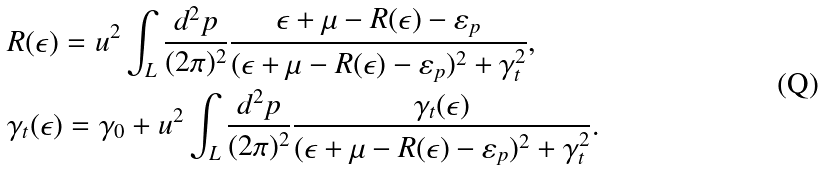Convert formula to latex. <formula><loc_0><loc_0><loc_500><loc_500>& R ( \epsilon ) = u ^ { 2 } \int _ { L } \frac { d ^ { 2 } p } { ( 2 \pi ) ^ { 2 } } \frac { \epsilon + \mu - R ( \epsilon ) - \varepsilon _ { p } } { ( \epsilon + \mu - R ( \epsilon ) - \varepsilon _ { p } ) ^ { 2 } + \gamma _ { t } ^ { 2 } } , \\ & \gamma _ { t } ( \epsilon ) = \gamma _ { 0 } + u ^ { 2 } \int _ { L } \frac { d ^ { 2 } p } { ( 2 \pi ) ^ { 2 } } \frac { \gamma _ { t } ( \epsilon ) } { ( \epsilon + \mu - R ( \epsilon ) - \varepsilon _ { p } ) ^ { 2 } + \gamma _ { t } ^ { 2 } } .</formula> 